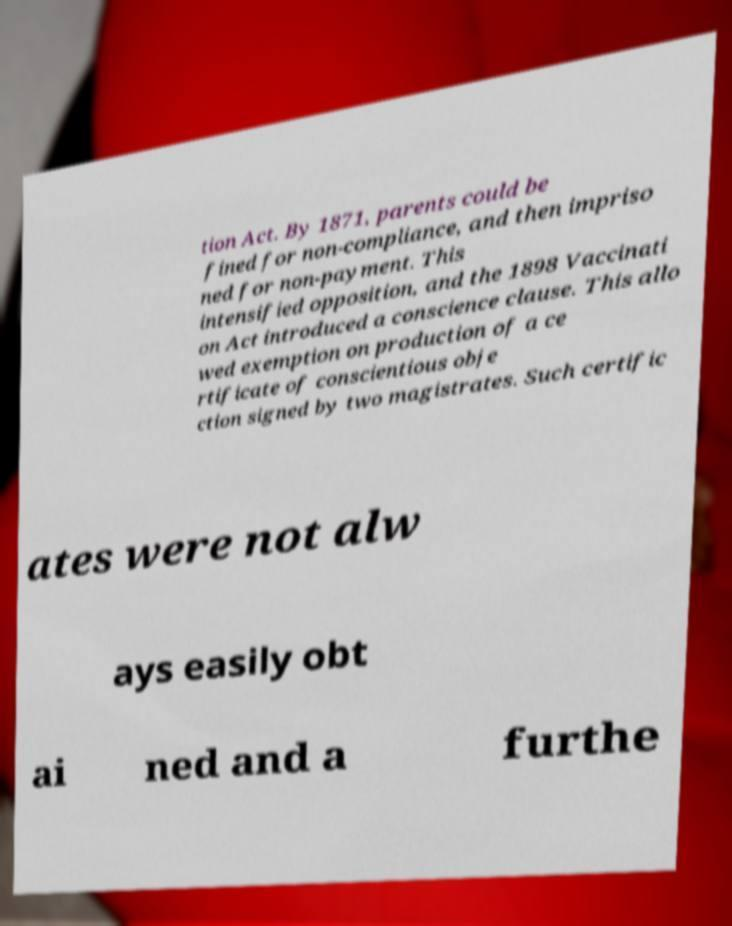Please read and relay the text visible in this image. What does it say? tion Act. By 1871, parents could be fined for non-compliance, and then impriso ned for non-payment. This intensified opposition, and the 1898 Vaccinati on Act introduced a conscience clause. This allo wed exemption on production of a ce rtificate of conscientious obje ction signed by two magistrates. Such certific ates were not alw ays easily obt ai ned and a furthe 